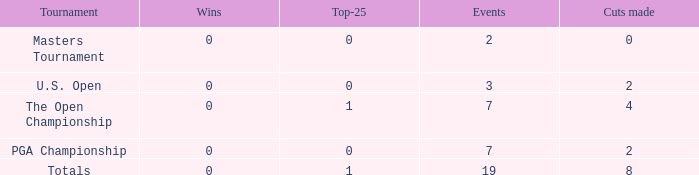What is the Wins of the Top-25 of 1 and 7 Events? 0.0. 